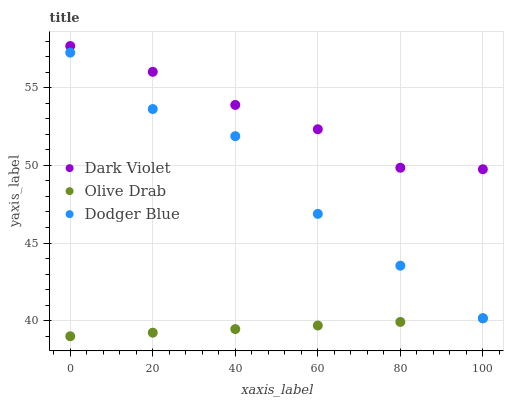Does Olive Drab have the minimum area under the curve?
Answer yes or no. Yes. Does Dark Violet have the maximum area under the curve?
Answer yes or no. Yes. Does Dark Violet have the minimum area under the curve?
Answer yes or no. No. Does Olive Drab have the maximum area under the curve?
Answer yes or no. No. Is Olive Drab the smoothest?
Answer yes or no. Yes. Is Dodger Blue the roughest?
Answer yes or no. Yes. Is Dark Violet the smoothest?
Answer yes or no. No. Is Dark Violet the roughest?
Answer yes or no. No. Does Olive Drab have the lowest value?
Answer yes or no. Yes. Does Dark Violet have the lowest value?
Answer yes or no. No. Does Dark Violet have the highest value?
Answer yes or no. Yes. Does Olive Drab have the highest value?
Answer yes or no. No. Is Olive Drab less than Dark Violet?
Answer yes or no. Yes. Is Dodger Blue greater than Olive Drab?
Answer yes or no. Yes. Does Olive Drab intersect Dark Violet?
Answer yes or no. No. 